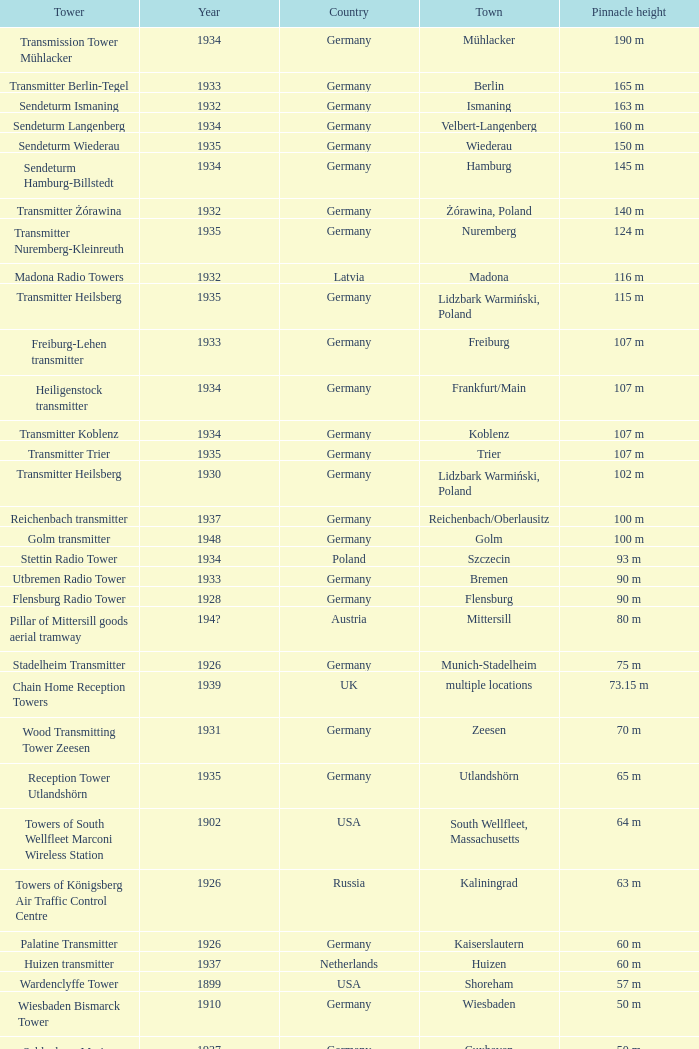Which country had a tower destroyed in 1899? USA. 